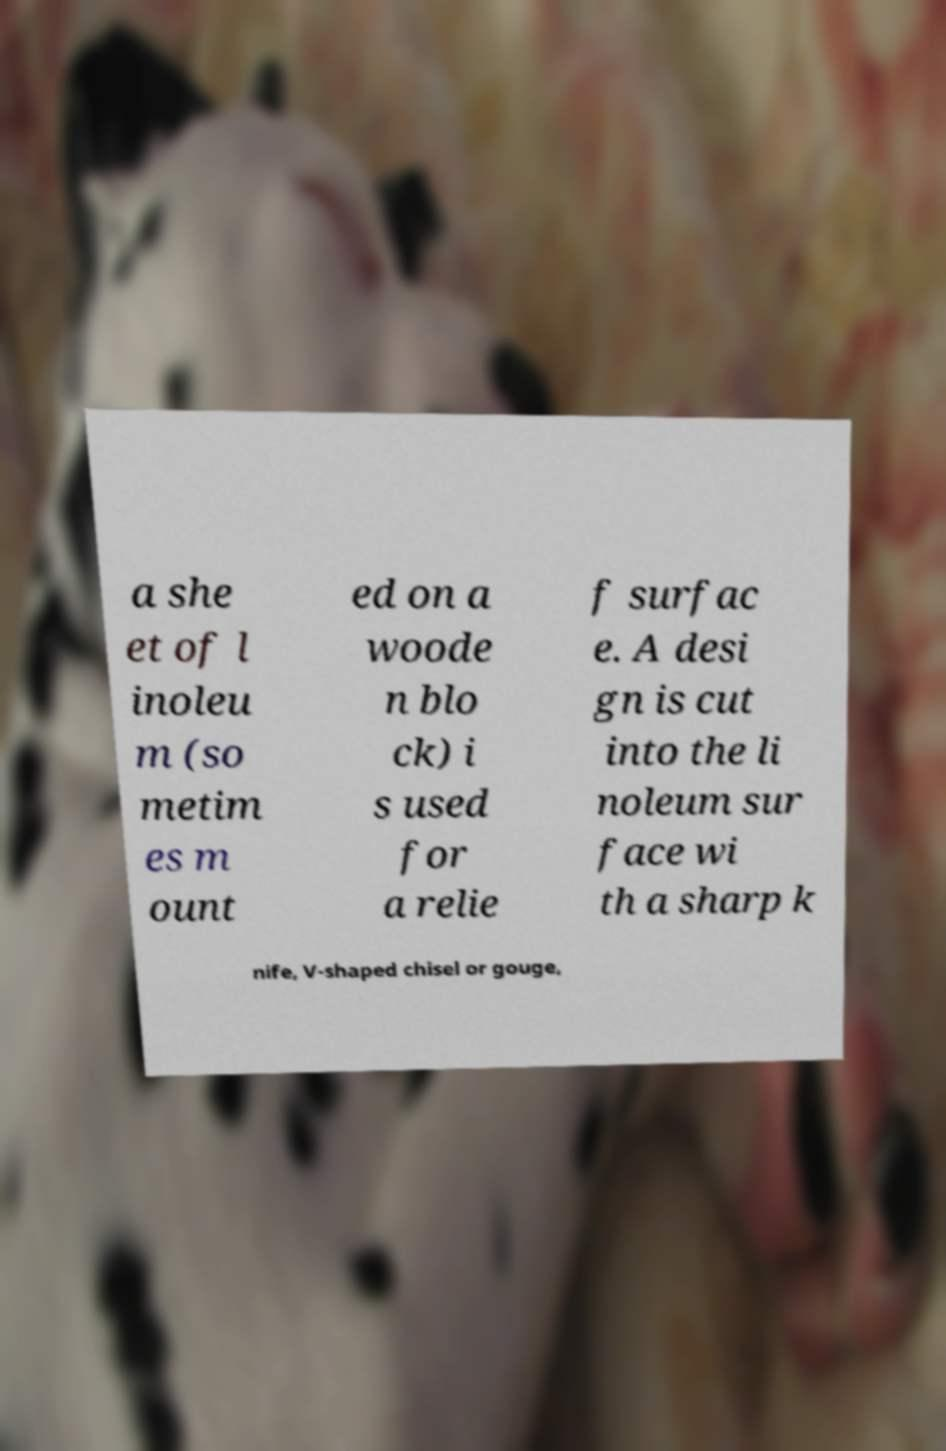Could you assist in decoding the text presented in this image and type it out clearly? a she et of l inoleu m (so metim es m ount ed on a woode n blo ck) i s used for a relie f surfac e. A desi gn is cut into the li noleum sur face wi th a sharp k nife, V-shaped chisel or gouge, 